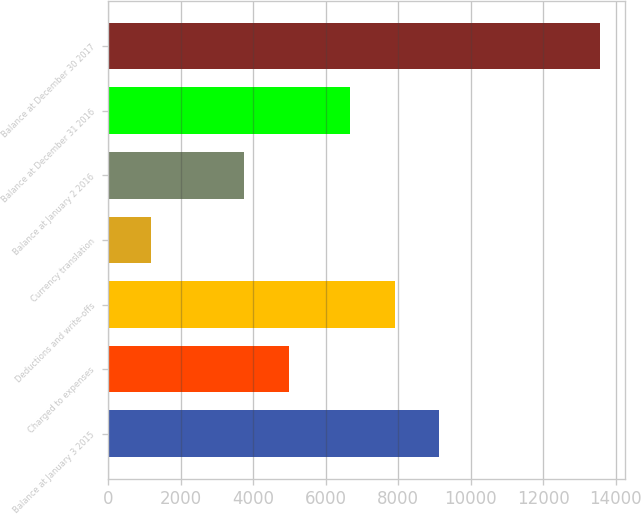Convert chart. <chart><loc_0><loc_0><loc_500><loc_500><bar_chart><fcel>Balance at January 3 2015<fcel>Charged to expenses<fcel>Deductions and write-offs<fcel>Currency translation<fcel>Balance at January 2 2016<fcel>Balance at December 31 2016<fcel>Balance at December 30 2017<nl><fcel>9136.4<fcel>4988.2<fcel>7897.2<fcel>1180<fcel>3749<fcel>6658<fcel>13572<nl></chart> 